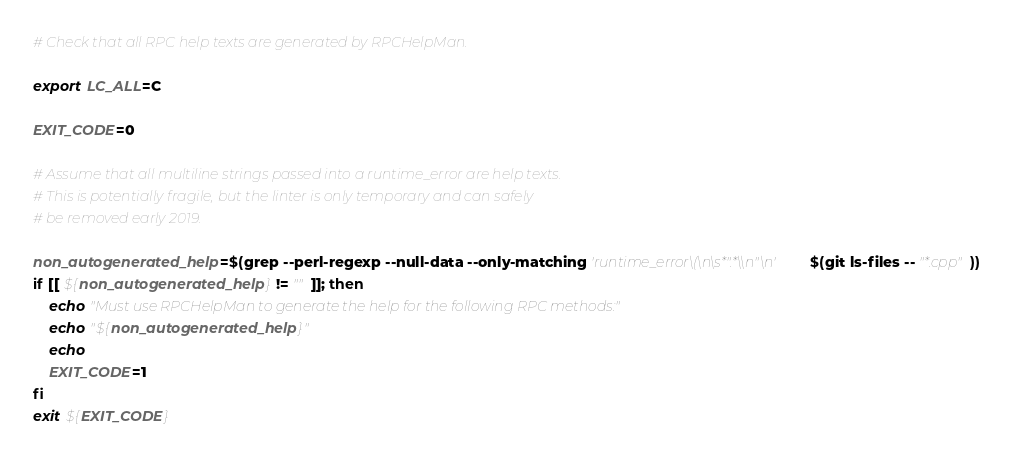Convert code to text. <code><loc_0><loc_0><loc_500><loc_500><_Bash_># Check that all RPC help texts are generated by RPCHelpMan.

export LC_ALL=C

EXIT_CODE=0

# Assume that all multiline strings passed into a runtime_error are help texts.
# This is potentially fragile, but the linter is only temporary and can safely
# be removed early 2019.

non_autogenerated_help=$(grep --perl-regexp --null-data --only-matching 'runtime_error\(\n\s*".*\\n"\n' $(git ls-files -- "*.cpp"))
if [[ ${non_autogenerated_help} != "" ]]; then
    echo "Must use RPCHelpMan to generate the help for the following RPC methods:"
    echo "${non_autogenerated_help}"
    echo
    EXIT_CODE=1
fi
exit ${EXIT_CODE}
</code> 